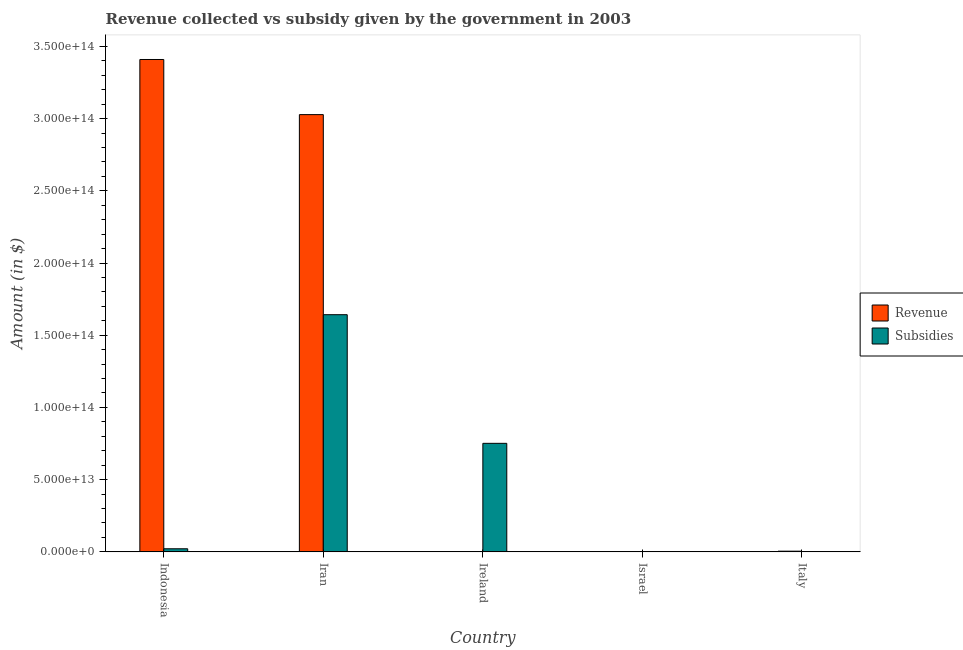How many groups of bars are there?
Ensure brevity in your answer.  5. How many bars are there on the 1st tick from the left?
Provide a short and direct response. 2. How many bars are there on the 3rd tick from the right?
Offer a terse response. 2. What is the amount of revenue collected in Italy?
Your answer should be compact. 4.81e+11. Across all countries, what is the maximum amount of subsidies given?
Ensure brevity in your answer.  1.64e+14. Across all countries, what is the minimum amount of revenue collected?
Provide a succinct answer. 4.25e+1. In which country was the amount of revenue collected maximum?
Give a very brief answer. Indonesia. What is the total amount of revenue collected in the graph?
Keep it short and to the point. 6.44e+14. What is the difference between the amount of subsidies given in Ireland and that in Israel?
Offer a very short reply. 7.51e+13. What is the difference between the amount of revenue collected in Iran and the amount of subsidies given in Israel?
Give a very brief answer. 3.03e+14. What is the average amount of revenue collected per country?
Give a very brief answer. 1.29e+14. What is the difference between the amount of subsidies given and amount of revenue collected in Ireland?
Ensure brevity in your answer.  7.51e+13. In how many countries, is the amount of revenue collected greater than 20000000000000 $?
Provide a succinct answer. 2. What is the ratio of the amount of revenue collected in Iran to that in Ireland?
Offer a very short reply. 7128.3. Is the amount of revenue collected in Indonesia less than that in Italy?
Make the answer very short. No. Is the difference between the amount of subsidies given in Indonesia and Israel greater than the difference between the amount of revenue collected in Indonesia and Israel?
Keep it short and to the point. No. What is the difference between the highest and the second highest amount of revenue collected?
Make the answer very short. 3.82e+13. What is the difference between the highest and the lowest amount of subsidies given?
Your answer should be compact. 1.64e+14. In how many countries, is the amount of subsidies given greater than the average amount of subsidies given taken over all countries?
Your response must be concise. 2. Is the sum of the amount of subsidies given in Indonesia and Italy greater than the maximum amount of revenue collected across all countries?
Give a very brief answer. No. What does the 1st bar from the left in Israel represents?
Offer a terse response. Revenue. What does the 2nd bar from the right in Israel represents?
Your answer should be very brief. Revenue. How many bars are there?
Ensure brevity in your answer.  10. Are all the bars in the graph horizontal?
Your response must be concise. No. What is the difference between two consecutive major ticks on the Y-axis?
Your response must be concise. 5.00e+13. Are the values on the major ticks of Y-axis written in scientific E-notation?
Keep it short and to the point. Yes. Does the graph contain grids?
Give a very brief answer. No. How many legend labels are there?
Offer a very short reply. 2. What is the title of the graph?
Your answer should be very brief. Revenue collected vs subsidy given by the government in 2003. Does "Short-term debt" appear as one of the legend labels in the graph?
Offer a terse response. No. What is the label or title of the X-axis?
Provide a short and direct response. Country. What is the label or title of the Y-axis?
Provide a succinct answer. Amount (in $). What is the Amount (in $) in Revenue in Indonesia?
Keep it short and to the point. 3.41e+14. What is the Amount (in $) of Subsidies in Indonesia?
Offer a terse response. 2.15e+12. What is the Amount (in $) in Revenue in Iran?
Provide a short and direct response. 3.03e+14. What is the Amount (in $) in Subsidies in Iran?
Provide a short and direct response. 1.64e+14. What is the Amount (in $) of Revenue in Ireland?
Give a very brief answer. 4.25e+1. What is the Amount (in $) of Subsidies in Ireland?
Give a very brief answer. 7.52e+13. What is the Amount (in $) of Revenue in Israel?
Provide a succinct answer. 2.11e+11. What is the Amount (in $) in Subsidies in Israel?
Your answer should be very brief. 1.19e+1. What is the Amount (in $) in Revenue in Italy?
Provide a short and direct response. 4.81e+11. What is the Amount (in $) in Subsidies in Italy?
Your answer should be compact. 7.74e+1. Across all countries, what is the maximum Amount (in $) in Revenue?
Your response must be concise. 3.41e+14. Across all countries, what is the maximum Amount (in $) of Subsidies?
Ensure brevity in your answer.  1.64e+14. Across all countries, what is the minimum Amount (in $) in Revenue?
Provide a short and direct response. 4.25e+1. Across all countries, what is the minimum Amount (in $) of Subsidies?
Offer a terse response. 1.19e+1. What is the total Amount (in $) in Revenue in the graph?
Offer a terse response. 6.44e+14. What is the total Amount (in $) of Subsidies in the graph?
Offer a terse response. 2.42e+14. What is the difference between the Amount (in $) in Revenue in Indonesia and that in Iran?
Your answer should be very brief. 3.82e+13. What is the difference between the Amount (in $) in Subsidies in Indonesia and that in Iran?
Your answer should be very brief. -1.62e+14. What is the difference between the Amount (in $) of Revenue in Indonesia and that in Ireland?
Your answer should be compact. 3.41e+14. What is the difference between the Amount (in $) in Subsidies in Indonesia and that in Ireland?
Make the answer very short. -7.30e+13. What is the difference between the Amount (in $) of Revenue in Indonesia and that in Israel?
Your answer should be very brief. 3.41e+14. What is the difference between the Amount (in $) in Subsidies in Indonesia and that in Israel?
Your answer should be compact. 2.13e+12. What is the difference between the Amount (in $) in Revenue in Indonesia and that in Italy?
Offer a very short reply. 3.40e+14. What is the difference between the Amount (in $) of Subsidies in Indonesia and that in Italy?
Your response must be concise. 2.07e+12. What is the difference between the Amount (in $) of Revenue in Iran and that in Ireland?
Your answer should be compact. 3.03e+14. What is the difference between the Amount (in $) in Subsidies in Iran and that in Ireland?
Ensure brevity in your answer.  8.91e+13. What is the difference between the Amount (in $) in Revenue in Iran and that in Israel?
Ensure brevity in your answer.  3.03e+14. What is the difference between the Amount (in $) of Subsidies in Iran and that in Israel?
Make the answer very short. 1.64e+14. What is the difference between the Amount (in $) in Revenue in Iran and that in Italy?
Your response must be concise. 3.02e+14. What is the difference between the Amount (in $) of Subsidies in Iran and that in Italy?
Make the answer very short. 1.64e+14. What is the difference between the Amount (in $) in Revenue in Ireland and that in Israel?
Your response must be concise. -1.68e+11. What is the difference between the Amount (in $) of Subsidies in Ireland and that in Israel?
Offer a very short reply. 7.51e+13. What is the difference between the Amount (in $) of Revenue in Ireland and that in Italy?
Ensure brevity in your answer.  -4.39e+11. What is the difference between the Amount (in $) in Subsidies in Ireland and that in Italy?
Your response must be concise. 7.51e+13. What is the difference between the Amount (in $) of Revenue in Israel and that in Italy?
Your response must be concise. -2.71e+11. What is the difference between the Amount (in $) in Subsidies in Israel and that in Italy?
Your answer should be very brief. -6.55e+1. What is the difference between the Amount (in $) in Revenue in Indonesia and the Amount (in $) in Subsidies in Iran?
Give a very brief answer. 1.77e+14. What is the difference between the Amount (in $) of Revenue in Indonesia and the Amount (in $) of Subsidies in Ireland?
Offer a very short reply. 2.66e+14. What is the difference between the Amount (in $) in Revenue in Indonesia and the Amount (in $) in Subsidies in Israel?
Your response must be concise. 3.41e+14. What is the difference between the Amount (in $) in Revenue in Indonesia and the Amount (in $) in Subsidies in Italy?
Your response must be concise. 3.41e+14. What is the difference between the Amount (in $) in Revenue in Iran and the Amount (in $) in Subsidies in Ireland?
Provide a succinct answer. 2.28e+14. What is the difference between the Amount (in $) of Revenue in Iran and the Amount (in $) of Subsidies in Israel?
Your response must be concise. 3.03e+14. What is the difference between the Amount (in $) in Revenue in Iran and the Amount (in $) in Subsidies in Italy?
Your response must be concise. 3.03e+14. What is the difference between the Amount (in $) in Revenue in Ireland and the Amount (in $) in Subsidies in Israel?
Provide a short and direct response. 3.06e+1. What is the difference between the Amount (in $) of Revenue in Ireland and the Amount (in $) of Subsidies in Italy?
Offer a terse response. -3.49e+1. What is the difference between the Amount (in $) of Revenue in Israel and the Amount (in $) of Subsidies in Italy?
Give a very brief answer. 1.33e+11. What is the average Amount (in $) in Revenue per country?
Make the answer very short. 1.29e+14. What is the average Amount (in $) in Subsidies per country?
Make the answer very short. 4.83e+13. What is the difference between the Amount (in $) in Revenue and Amount (in $) in Subsidies in Indonesia?
Offer a terse response. 3.39e+14. What is the difference between the Amount (in $) of Revenue and Amount (in $) of Subsidies in Iran?
Give a very brief answer. 1.39e+14. What is the difference between the Amount (in $) of Revenue and Amount (in $) of Subsidies in Ireland?
Your response must be concise. -7.51e+13. What is the difference between the Amount (in $) of Revenue and Amount (in $) of Subsidies in Israel?
Ensure brevity in your answer.  1.99e+11. What is the difference between the Amount (in $) in Revenue and Amount (in $) in Subsidies in Italy?
Provide a succinct answer. 4.04e+11. What is the ratio of the Amount (in $) in Revenue in Indonesia to that in Iran?
Your answer should be very brief. 1.13. What is the ratio of the Amount (in $) in Subsidies in Indonesia to that in Iran?
Your response must be concise. 0.01. What is the ratio of the Amount (in $) in Revenue in Indonesia to that in Ireland?
Your answer should be very brief. 8026.81. What is the ratio of the Amount (in $) in Subsidies in Indonesia to that in Ireland?
Offer a very short reply. 0.03. What is the ratio of the Amount (in $) in Revenue in Indonesia to that in Israel?
Make the answer very short. 1619.36. What is the ratio of the Amount (in $) of Subsidies in Indonesia to that in Israel?
Offer a terse response. 180.79. What is the ratio of the Amount (in $) in Revenue in Indonesia to that in Italy?
Ensure brevity in your answer.  708.19. What is the ratio of the Amount (in $) of Subsidies in Indonesia to that in Italy?
Give a very brief answer. 27.74. What is the ratio of the Amount (in $) of Revenue in Iran to that in Ireland?
Your response must be concise. 7128.3. What is the ratio of the Amount (in $) in Subsidies in Iran to that in Ireland?
Provide a succinct answer. 2.19. What is the ratio of the Amount (in $) in Revenue in Iran to that in Israel?
Keep it short and to the point. 1438.09. What is the ratio of the Amount (in $) in Subsidies in Iran to that in Israel?
Your answer should be compact. 1.38e+04. What is the ratio of the Amount (in $) in Revenue in Iran to that in Italy?
Offer a terse response. 628.92. What is the ratio of the Amount (in $) in Subsidies in Iran to that in Italy?
Ensure brevity in your answer.  2122.54. What is the ratio of the Amount (in $) of Revenue in Ireland to that in Israel?
Ensure brevity in your answer.  0.2. What is the ratio of the Amount (in $) in Subsidies in Ireland to that in Israel?
Your answer should be very brief. 6331.69. What is the ratio of the Amount (in $) of Revenue in Ireland to that in Italy?
Your response must be concise. 0.09. What is the ratio of the Amount (in $) in Subsidies in Ireland to that in Italy?
Offer a very short reply. 971.38. What is the ratio of the Amount (in $) of Revenue in Israel to that in Italy?
Offer a terse response. 0.44. What is the ratio of the Amount (in $) in Subsidies in Israel to that in Italy?
Your answer should be compact. 0.15. What is the difference between the highest and the second highest Amount (in $) in Revenue?
Your answer should be compact. 3.82e+13. What is the difference between the highest and the second highest Amount (in $) in Subsidies?
Make the answer very short. 8.91e+13. What is the difference between the highest and the lowest Amount (in $) in Revenue?
Give a very brief answer. 3.41e+14. What is the difference between the highest and the lowest Amount (in $) in Subsidies?
Provide a succinct answer. 1.64e+14. 